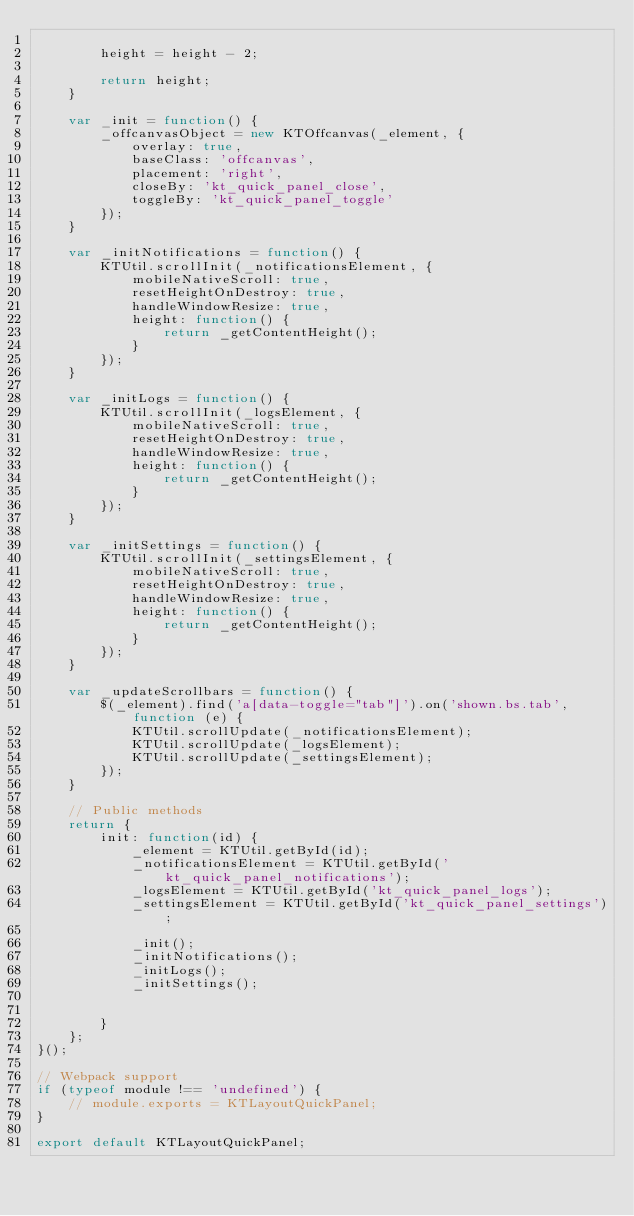<code> <loc_0><loc_0><loc_500><loc_500><_JavaScript_>
        height = height - 2;

        return height;
    }

    var _init = function() {
        _offcanvasObject = new KTOffcanvas(_element, {
            overlay: true,
            baseClass: 'offcanvas',
            placement: 'right',
            closeBy: 'kt_quick_panel_close',
            toggleBy: 'kt_quick_panel_toggle'
        });
    }

    var _initNotifications = function() {
        KTUtil.scrollInit(_notificationsElement, {
            mobileNativeScroll: true,
            resetHeightOnDestroy: true,
            handleWindowResize: true,
            height: function() {
                return _getContentHeight();
            }
        });
    }

    var _initLogs = function() {
        KTUtil.scrollInit(_logsElement, {
            mobileNativeScroll: true,
            resetHeightOnDestroy: true,
            handleWindowResize: true,
            height: function() {
                return _getContentHeight();
            }
        });
    }

    var _initSettings = function() {
        KTUtil.scrollInit(_settingsElement, {
            mobileNativeScroll: true,
            resetHeightOnDestroy: true,
            handleWindowResize: true,
            height: function() {
                return _getContentHeight();
            }
        });
    }

    var _updateScrollbars = function() {
        $(_element).find('a[data-toggle="tab"]').on('shown.bs.tab', function (e) {
            KTUtil.scrollUpdate(_notificationsElement);
            KTUtil.scrollUpdate(_logsElement);
            KTUtil.scrollUpdate(_settingsElement);
        });
    }

    // Public methods
    return {
        init: function(id) {
            _element = KTUtil.getById(id);
            _notificationsElement = KTUtil.getById('kt_quick_panel_notifications');
            _logsElement = KTUtil.getById('kt_quick_panel_logs');
            _settingsElement = KTUtil.getById('kt_quick_panel_settings');

            _init();
            _initNotifications();
            _initLogs();
            _initSettings();

            
        }
    };
}();

// Webpack support
if (typeof module !== 'undefined') {
	// module.exports = KTLayoutQuickPanel;
}

export default KTLayoutQuickPanel;</code> 